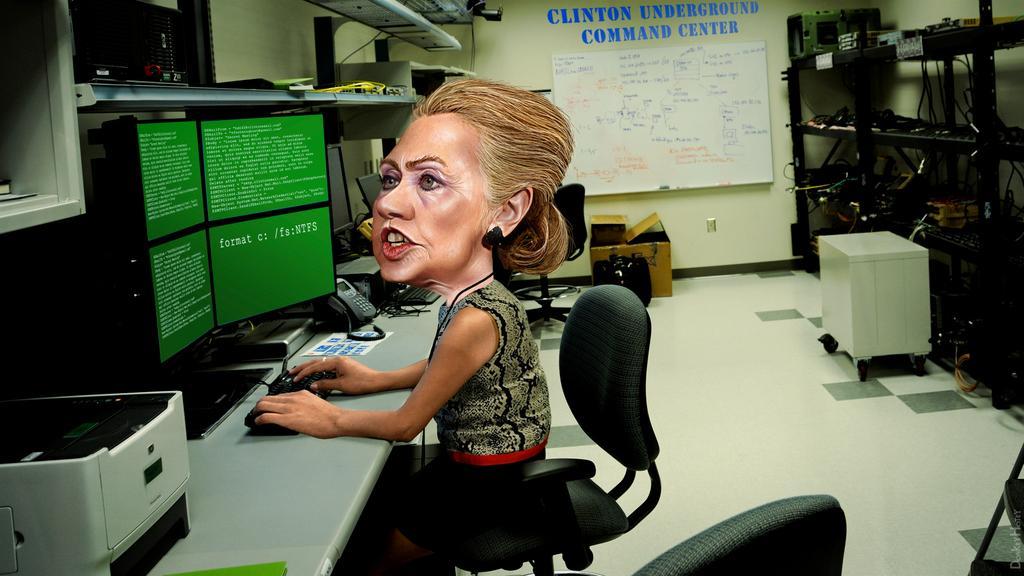Can you describe this image briefly? In the image wee can see there is a woman who is sitting on chair and in front of her there is a monitor and she is typing on keyboard and beside there on the table is a telephone and on the back on the wall there is a notice board. 